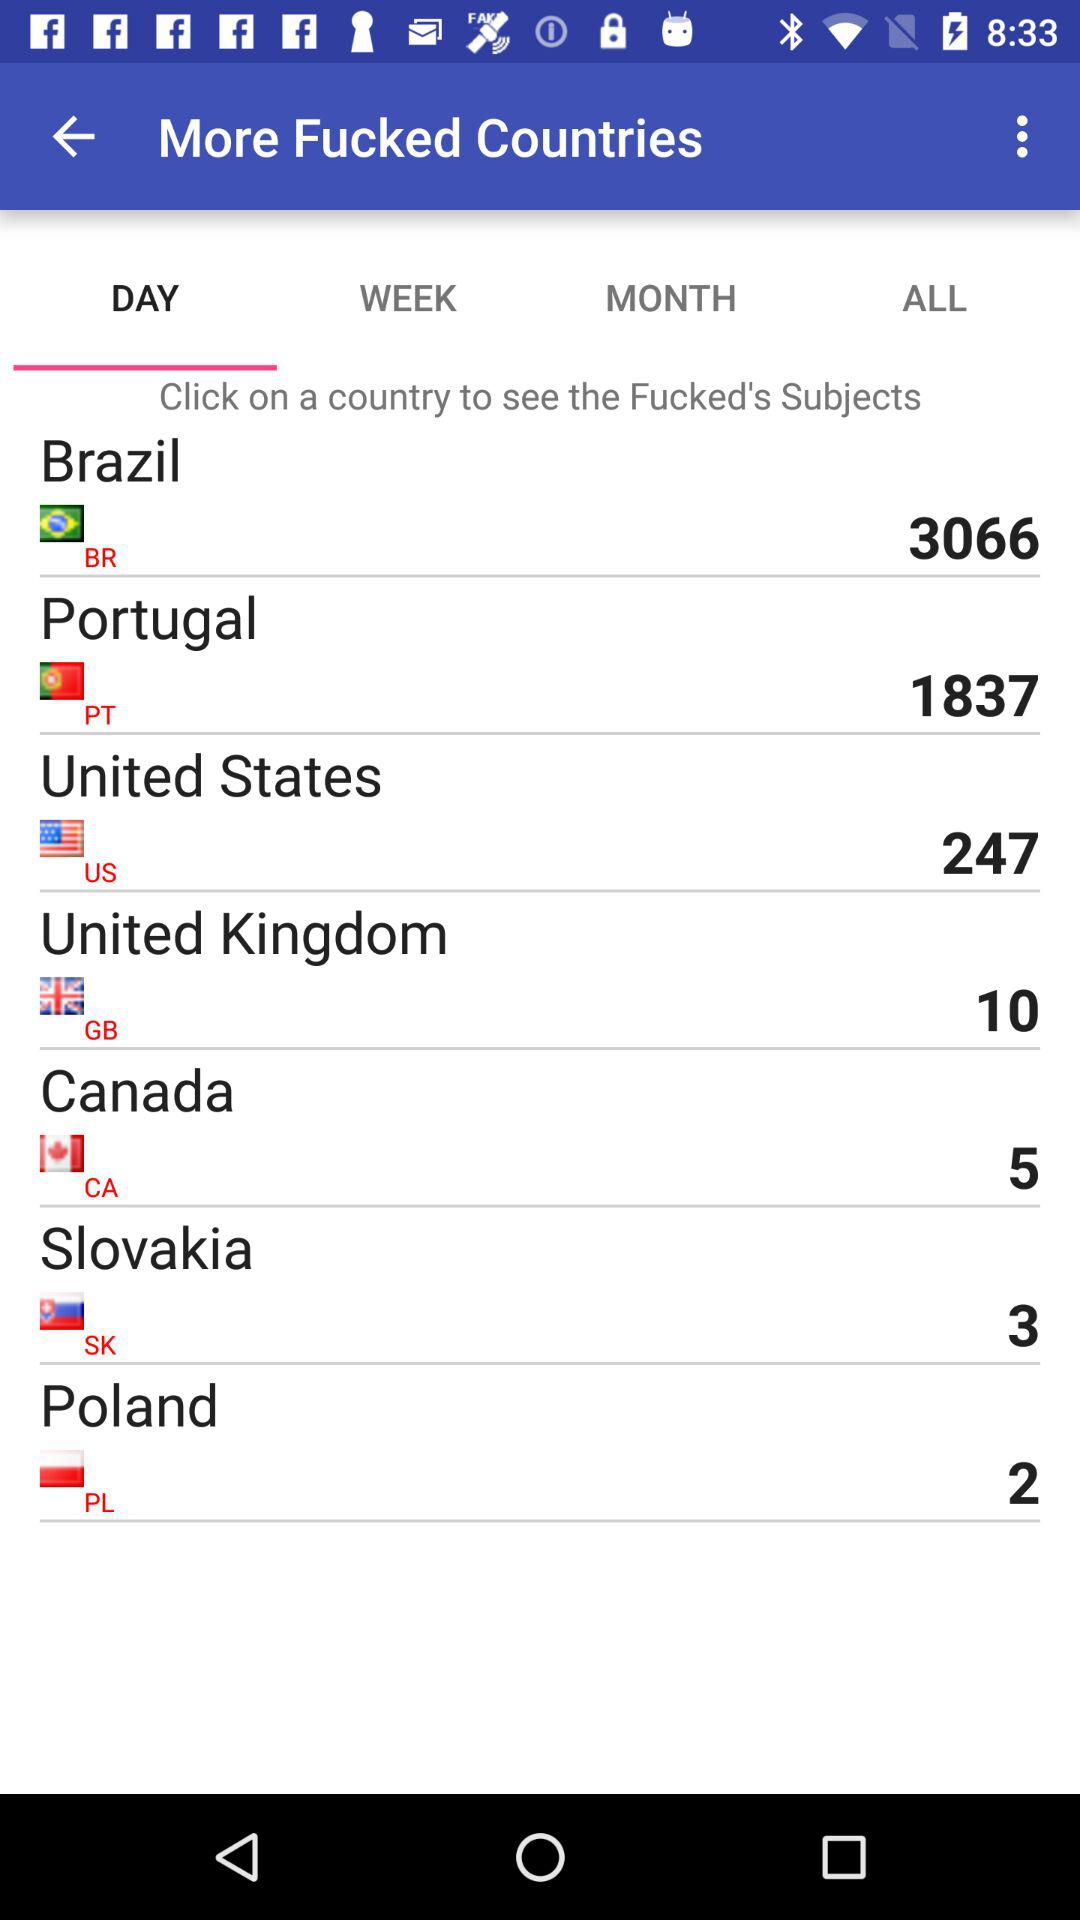Which tab has been selected? The tab that has been selected is "DAY". 